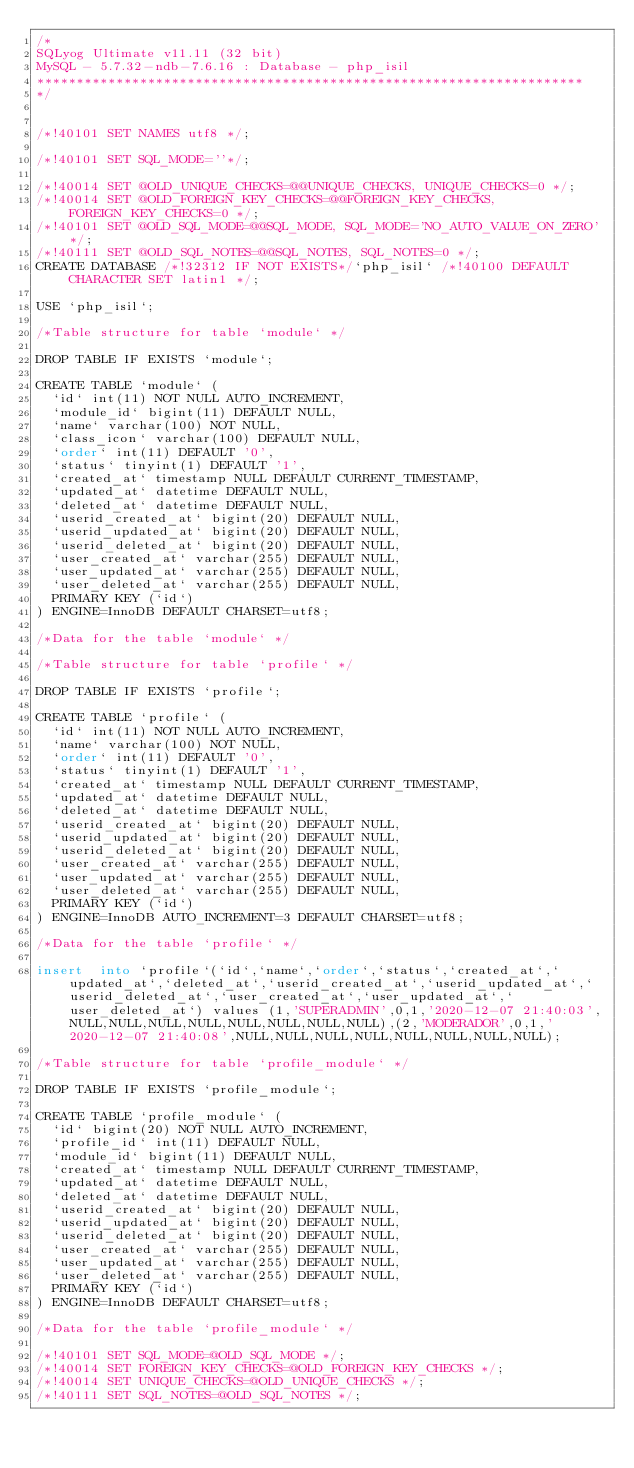<code> <loc_0><loc_0><loc_500><loc_500><_SQL_>/*
SQLyog Ultimate v11.11 (32 bit)
MySQL - 5.7.32-ndb-7.6.16 : Database - php_isil
*********************************************************************
*/

/*!40101 SET NAMES utf8 */;

/*!40101 SET SQL_MODE=''*/;

/*!40014 SET @OLD_UNIQUE_CHECKS=@@UNIQUE_CHECKS, UNIQUE_CHECKS=0 */;
/*!40014 SET @OLD_FOREIGN_KEY_CHECKS=@@FOREIGN_KEY_CHECKS, FOREIGN_KEY_CHECKS=0 */;
/*!40101 SET @OLD_SQL_MODE=@@SQL_MODE, SQL_MODE='NO_AUTO_VALUE_ON_ZERO' */;
/*!40111 SET @OLD_SQL_NOTES=@@SQL_NOTES, SQL_NOTES=0 */;
CREATE DATABASE /*!32312 IF NOT EXISTS*/`php_isil` /*!40100 DEFAULT CHARACTER SET latin1 */;

USE `php_isil`;

/*Table structure for table `module` */

DROP TABLE IF EXISTS `module`;

CREATE TABLE `module` (
  `id` int(11) NOT NULL AUTO_INCREMENT,
  `module_id` bigint(11) DEFAULT NULL,
  `name` varchar(100) NOT NULL,
  `class_icon` varchar(100) DEFAULT NULL,
  `order` int(11) DEFAULT '0',
  `status` tinyint(1) DEFAULT '1',
  `created_at` timestamp NULL DEFAULT CURRENT_TIMESTAMP,
  `updated_at` datetime DEFAULT NULL,
  `deleted_at` datetime DEFAULT NULL,
  `userid_created_at` bigint(20) DEFAULT NULL,
  `userid_updated_at` bigint(20) DEFAULT NULL,
  `userid_deleted_at` bigint(20) DEFAULT NULL,
  `user_created_at` varchar(255) DEFAULT NULL,
  `user_updated_at` varchar(255) DEFAULT NULL,
  `user_deleted_at` varchar(255) DEFAULT NULL,
  PRIMARY KEY (`id`)
) ENGINE=InnoDB DEFAULT CHARSET=utf8;

/*Data for the table `module` */

/*Table structure for table `profile` */

DROP TABLE IF EXISTS `profile`;

CREATE TABLE `profile` (
  `id` int(11) NOT NULL AUTO_INCREMENT,
  `name` varchar(100) NOT NULL,
  `order` int(11) DEFAULT '0',
  `status` tinyint(1) DEFAULT '1',
  `created_at` timestamp NULL DEFAULT CURRENT_TIMESTAMP,
  `updated_at` datetime DEFAULT NULL,
  `deleted_at` datetime DEFAULT NULL,
  `userid_created_at` bigint(20) DEFAULT NULL,
  `userid_updated_at` bigint(20) DEFAULT NULL,
  `userid_deleted_at` bigint(20) DEFAULT NULL,
  `user_created_at` varchar(255) DEFAULT NULL,
  `user_updated_at` varchar(255) DEFAULT NULL,
  `user_deleted_at` varchar(255) DEFAULT NULL,
  PRIMARY KEY (`id`)
) ENGINE=InnoDB AUTO_INCREMENT=3 DEFAULT CHARSET=utf8;

/*Data for the table `profile` */

insert  into `profile`(`id`,`name`,`order`,`status`,`created_at`,`updated_at`,`deleted_at`,`userid_created_at`,`userid_updated_at`,`userid_deleted_at`,`user_created_at`,`user_updated_at`,`user_deleted_at`) values (1,'SUPERADMIN',0,1,'2020-12-07 21:40:03',NULL,NULL,NULL,NULL,NULL,NULL,NULL,NULL),(2,'MODERADOR',0,1,'2020-12-07 21:40:08',NULL,NULL,NULL,NULL,NULL,NULL,NULL,NULL);

/*Table structure for table `profile_module` */

DROP TABLE IF EXISTS `profile_module`;

CREATE TABLE `profile_module` (
  `id` bigint(20) NOT NULL AUTO_INCREMENT,
  `profile_id` int(11) DEFAULT NULL,
  `module_id` bigint(11) DEFAULT NULL,
  `created_at` timestamp NULL DEFAULT CURRENT_TIMESTAMP,
  `updated_at` datetime DEFAULT NULL,
  `deleted_at` datetime DEFAULT NULL,
  `userid_created_at` bigint(20) DEFAULT NULL,
  `userid_updated_at` bigint(20) DEFAULT NULL,
  `userid_deleted_at` bigint(20) DEFAULT NULL,
  `user_created_at` varchar(255) DEFAULT NULL,
  `user_updated_at` varchar(255) DEFAULT NULL,
  `user_deleted_at` varchar(255) DEFAULT NULL,
  PRIMARY KEY (`id`)
) ENGINE=InnoDB DEFAULT CHARSET=utf8;

/*Data for the table `profile_module` */

/*!40101 SET SQL_MODE=@OLD_SQL_MODE */;
/*!40014 SET FOREIGN_KEY_CHECKS=@OLD_FOREIGN_KEY_CHECKS */;
/*!40014 SET UNIQUE_CHECKS=@OLD_UNIQUE_CHECKS */;
/*!40111 SET SQL_NOTES=@OLD_SQL_NOTES */;
</code> 